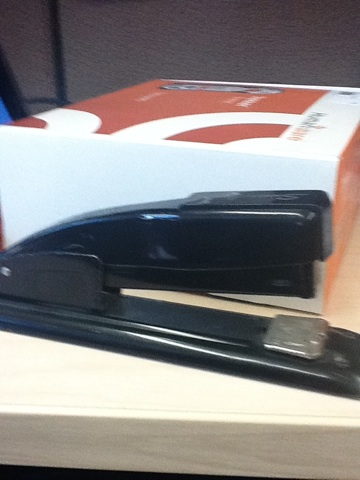What's that white box in the background? The white box in the background appears to be a box of printer or copier paper. These boxes are typically found in office settings and contain multiple reams of paper used for printers, copiers, or general office use. Can you describe a realistic scenario using what you see in the image? Sure! In a typical office setting, an employee might have a stack of reports that need to be stapled together. They reach for the stapler on their desk, load it with staples if necessary, and then proceed to staple the reports together. The box of printer paper in the background suggests that there is a nearby printer or copier, and the employee might have just printed or copied the reports before stapling them. What's another scenario? Another scenario could be a student working on a school project at home. They have just finished typing and printing their project, and now they need to bind the pages together. They use the stapler seen in the image to staple the pages into a neat and organized document, ready for submission. 